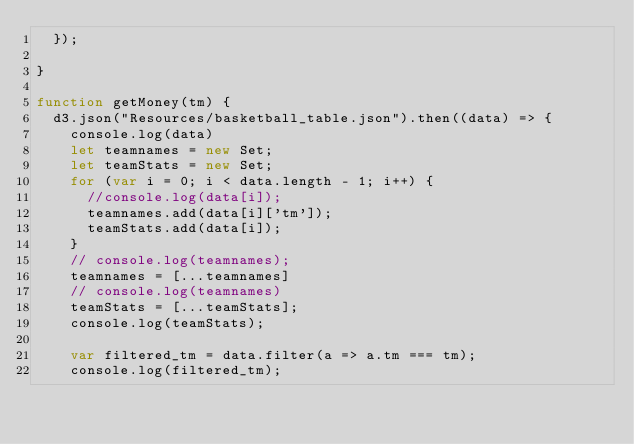<code> <loc_0><loc_0><loc_500><loc_500><_JavaScript_>  });

}

function getMoney(tm) {
  d3.json("Resources/basketball_table.json").then((data) => {
    console.log(data)
    let teamnames = new Set;
    let teamStats = new Set;
    for (var i = 0; i < data.length - 1; i++) {
      //console.log(data[i]);
      teamnames.add(data[i]['tm']);
      teamStats.add(data[i]);
    }
    // console.log(teamnames);
    teamnames = [...teamnames]
    // console.log(teamnames)
    teamStats = [...teamStats];
    console.log(teamStats);

    var filtered_tm = data.filter(a => a.tm === tm);
    console.log(filtered_tm);</code> 